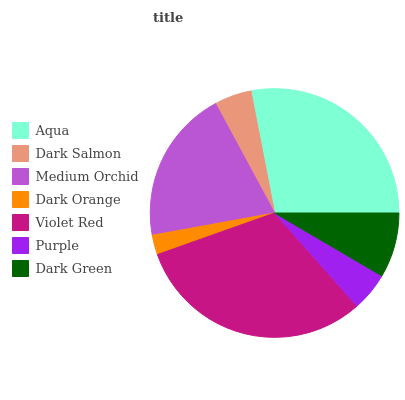Is Dark Orange the minimum?
Answer yes or no. Yes. Is Violet Red the maximum?
Answer yes or no. Yes. Is Dark Salmon the minimum?
Answer yes or no. No. Is Dark Salmon the maximum?
Answer yes or no. No. Is Aqua greater than Dark Salmon?
Answer yes or no. Yes. Is Dark Salmon less than Aqua?
Answer yes or no. Yes. Is Dark Salmon greater than Aqua?
Answer yes or no. No. Is Aqua less than Dark Salmon?
Answer yes or no. No. Is Dark Green the high median?
Answer yes or no. Yes. Is Dark Green the low median?
Answer yes or no. Yes. Is Medium Orchid the high median?
Answer yes or no. No. Is Dark Orange the low median?
Answer yes or no. No. 